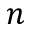Convert formula to latex. <formula><loc_0><loc_0><loc_500><loc_500>n</formula> 